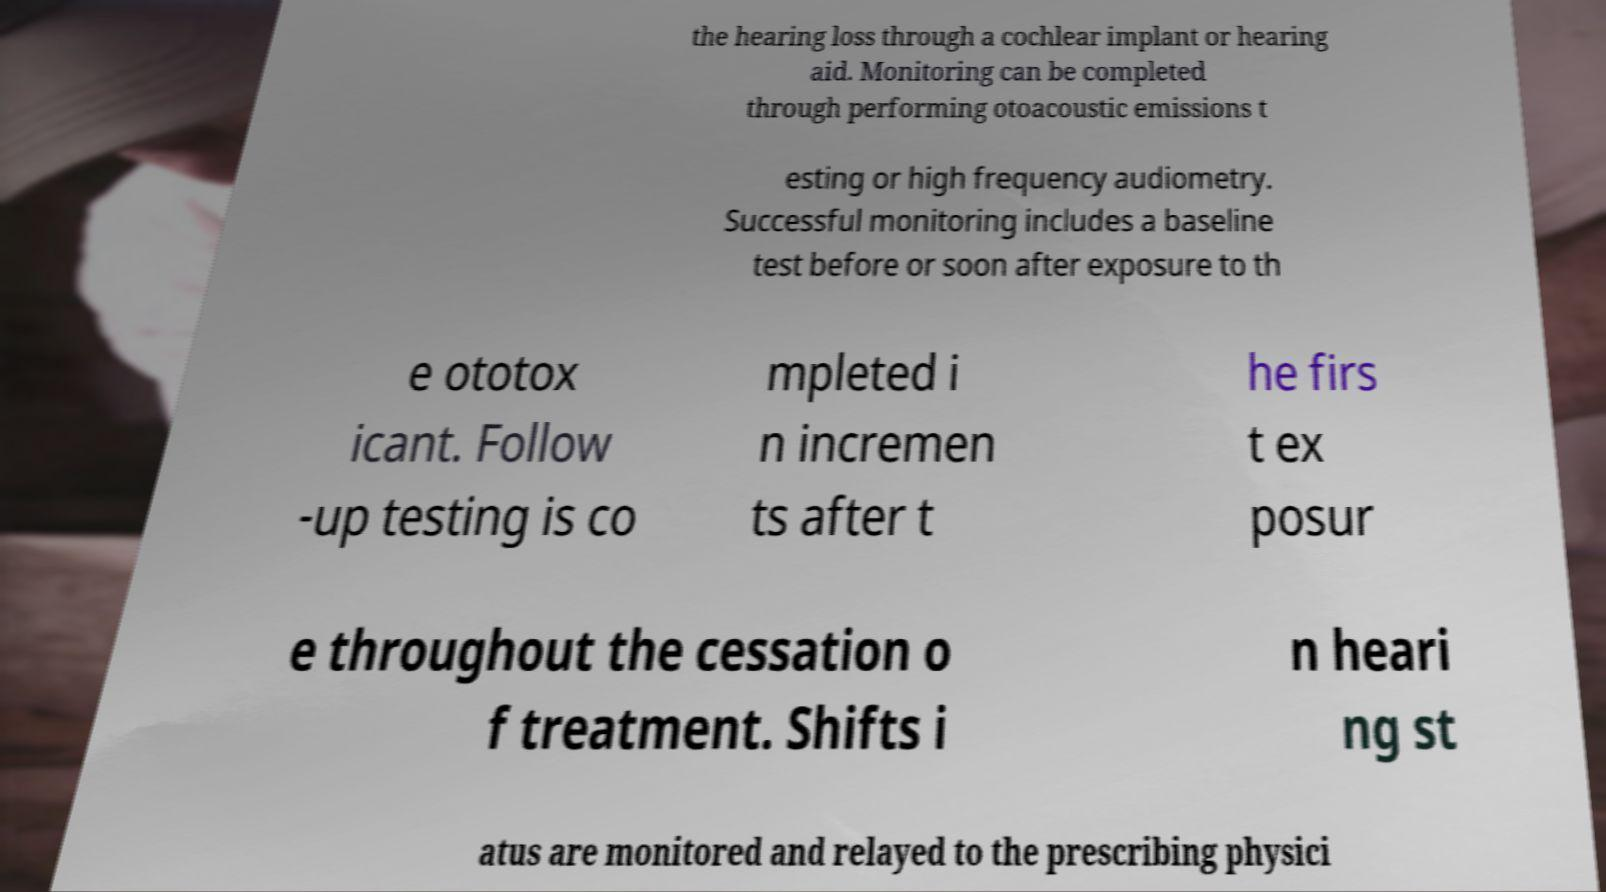Please read and relay the text visible in this image. What does it say? the hearing loss through a cochlear implant or hearing aid. Monitoring can be completed through performing otoacoustic emissions t esting or high frequency audiometry. Successful monitoring includes a baseline test before or soon after exposure to th e ototox icant. Follow -up testing is co mpleted i n incremen ts after t he firs t ex posur e throughout the cessation o f treatment. Shifts i n heari ng st atus are monitored and relayed to the prescribing physici 